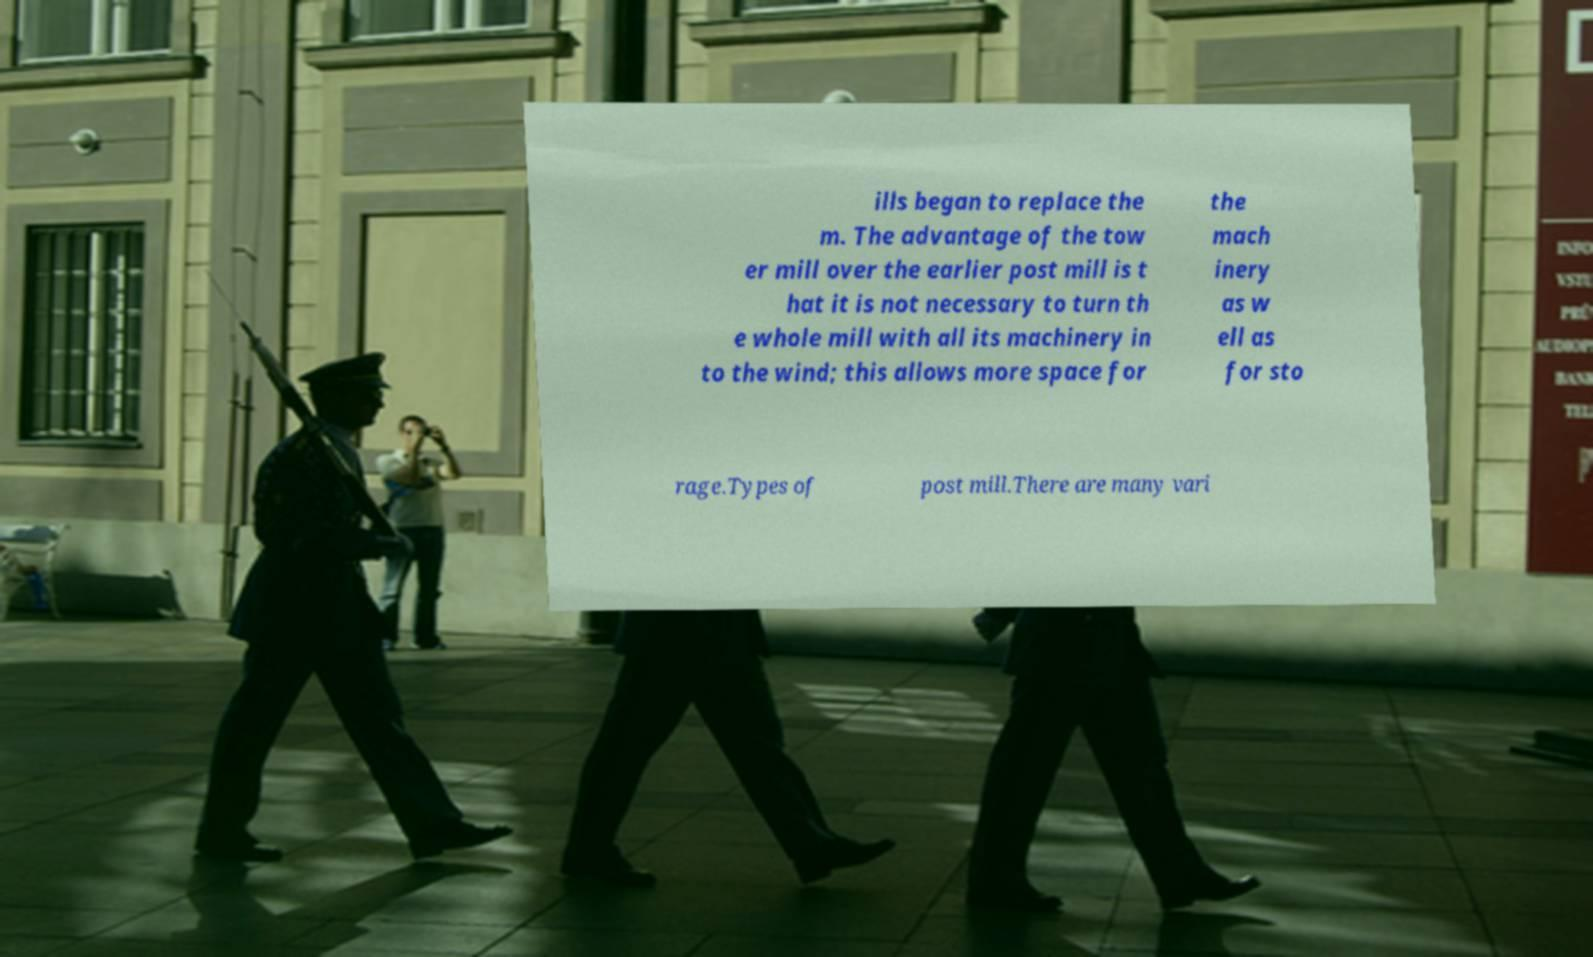Can you accurately transcribe the text from the provided image for me? ills began to replace the m. The advantage of the tow er mill over the earlier post mill is t hat it is not necessary to turn th e whole mill with all its machinery in to the wind; this allows more space for the mach inery as w ell as for sto rage.Types of post mill.There are many vari 